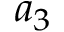Convert formula to latex. <formula><loc_0><loc_0><loc_500><loc_500>a _ { 3 }</formula> 